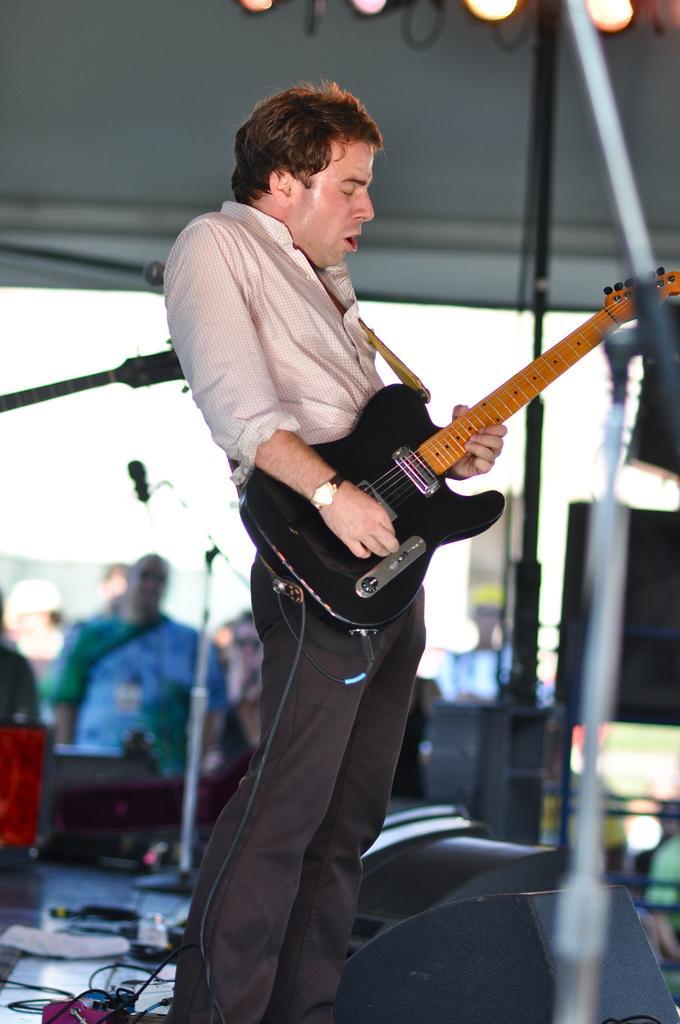Please provide a concise description of this image. In the image we can see there is a man who is holding a guitar in his hand and at the background the image is blur. 